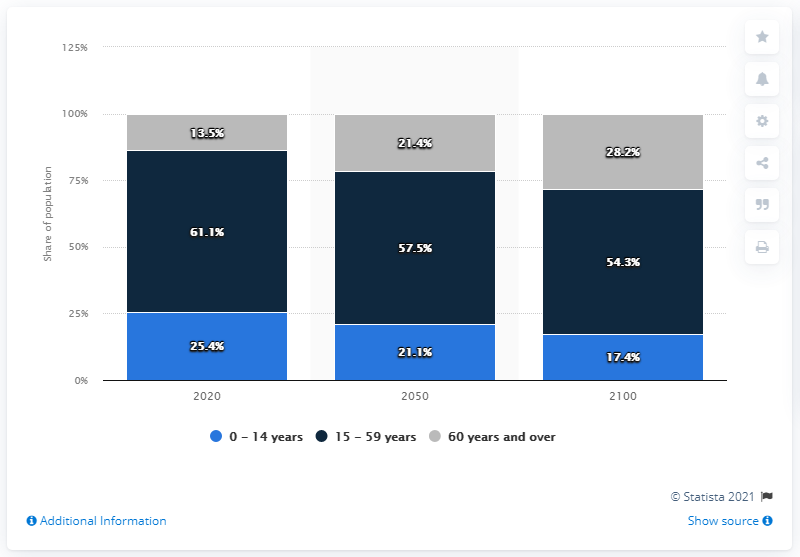Highlight a few significant elements in this photo. The sum of blue and dark blue percentage values in the year 2100 is 71.7%. In 2020, the value represented by the dark blue bar was 61.1%. 